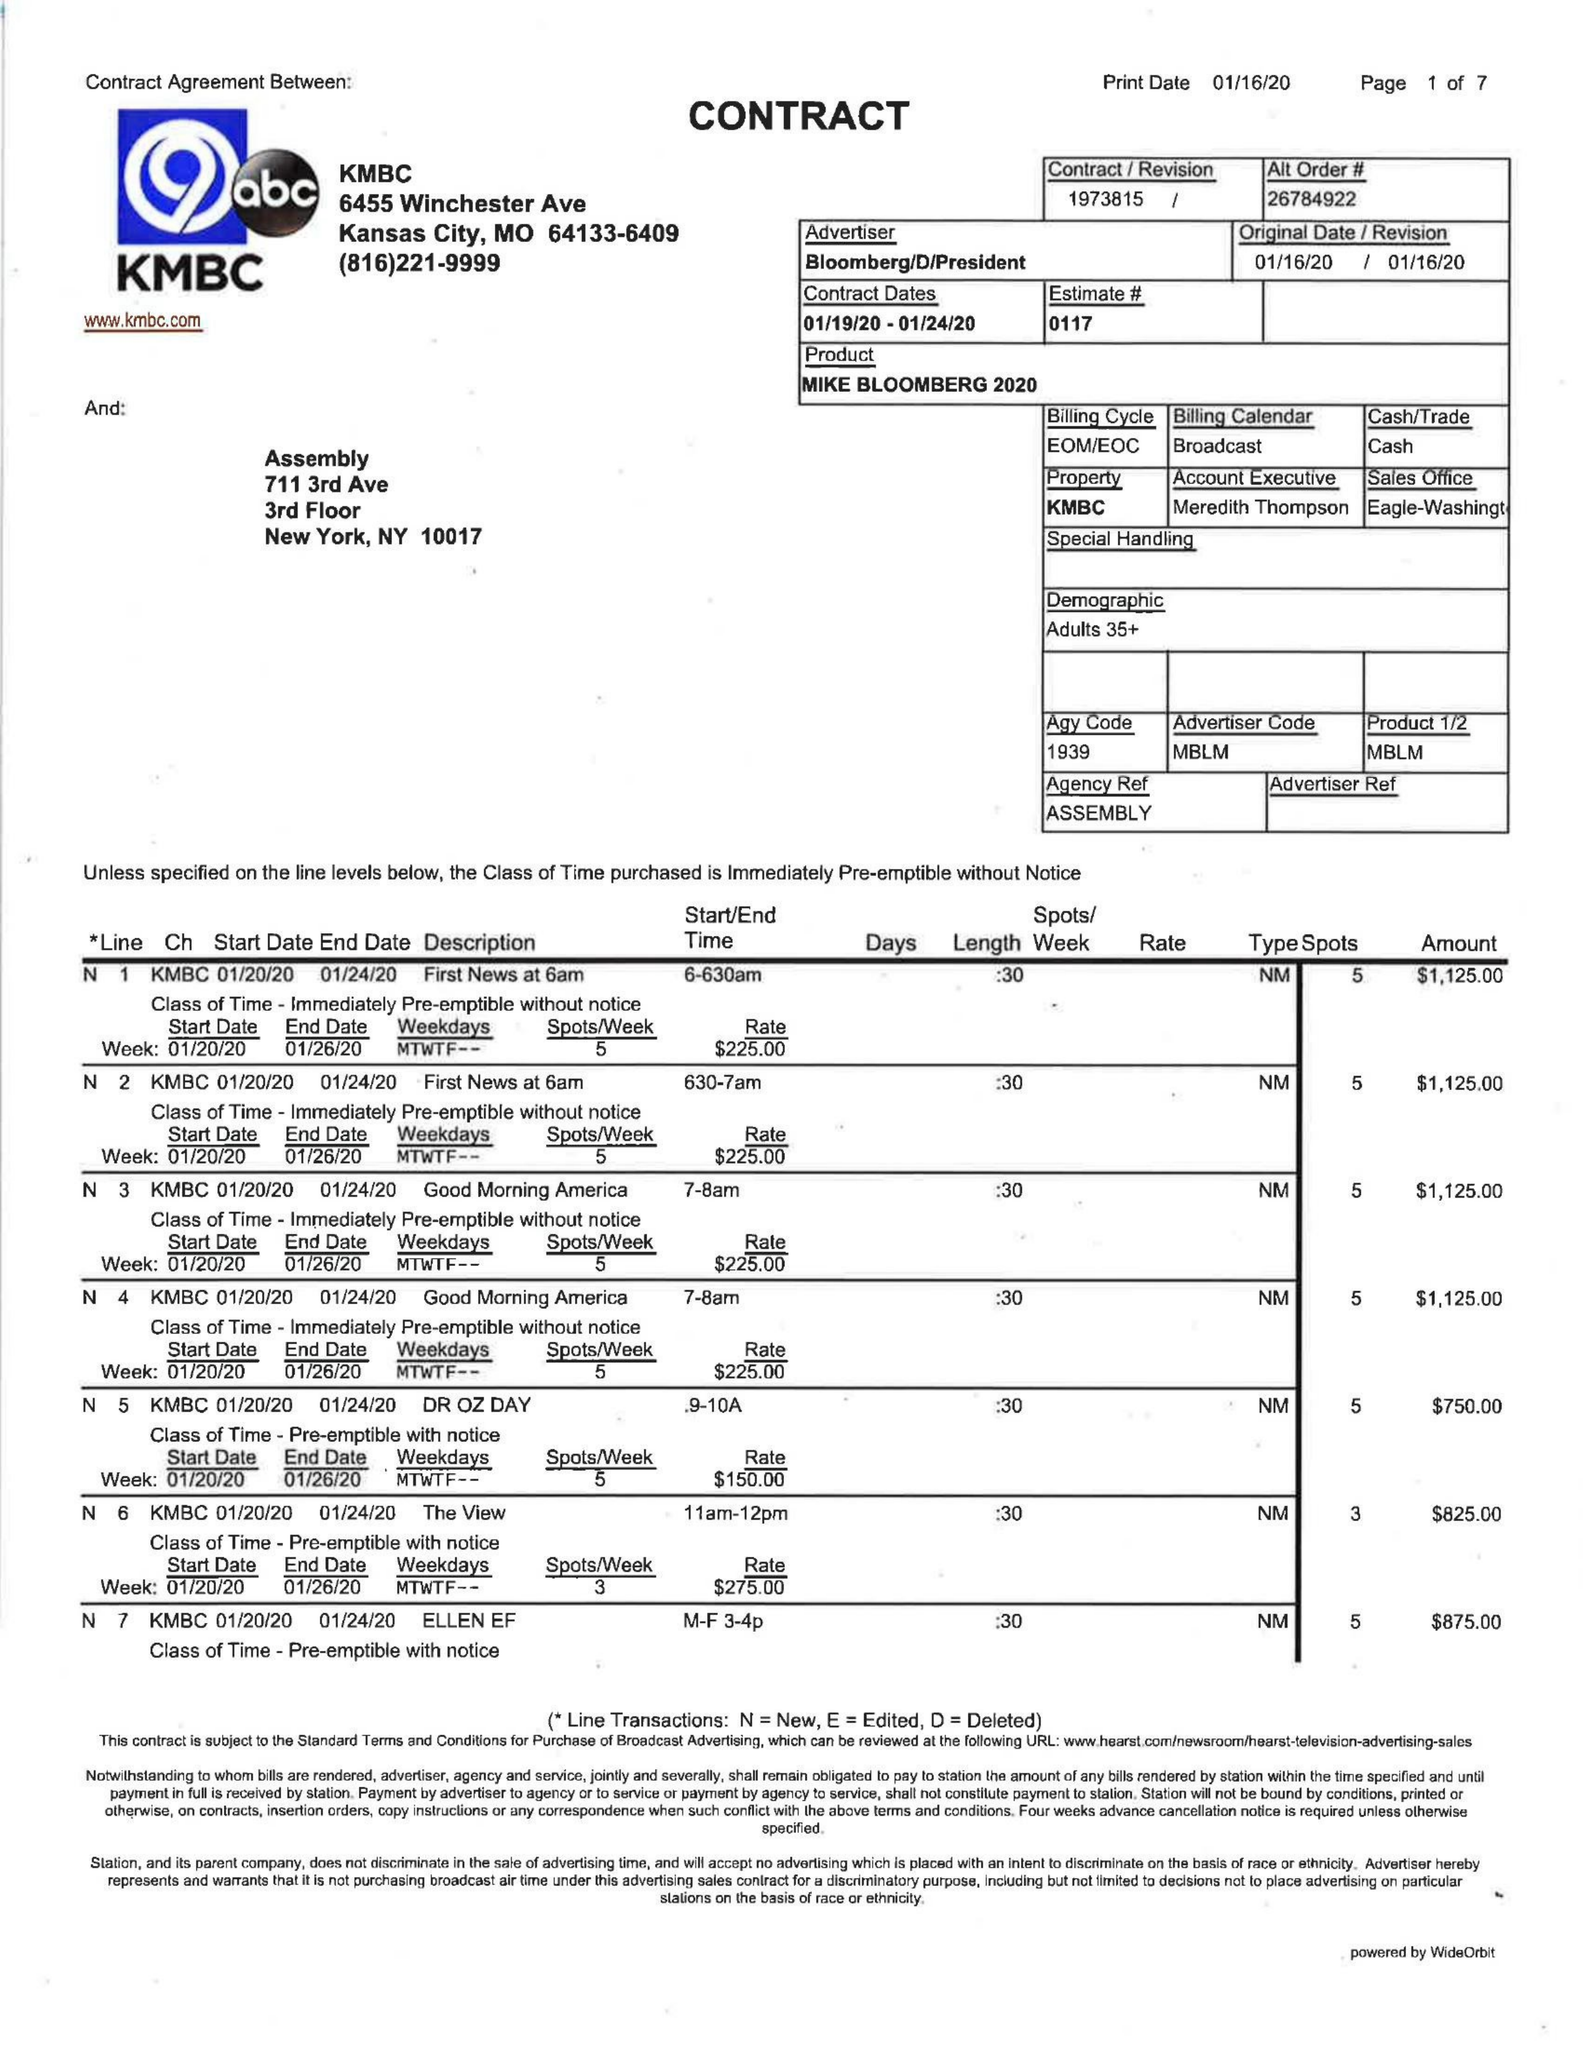What is the value for the advertiser?
Answer the question using a single word or phrase. BLOOMBERG/D/PRESIDENT 